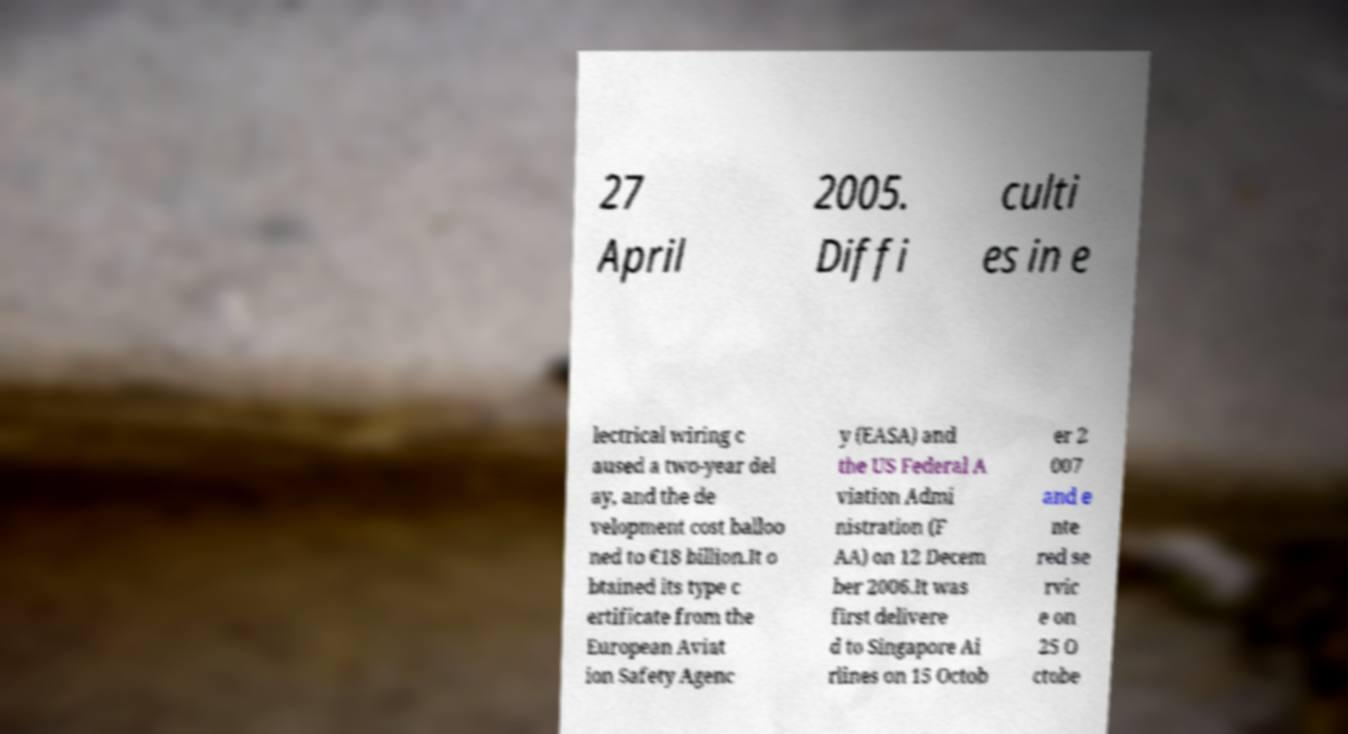Please identify and transcribe the text found in this image. 27 April 2005. Diffi culti es in e lectrical wiring c aused a two-year del ay, and the de velopment cost balloo ned to €18 billion.It o btained its type c ertificate from the European Aviat ion Safety Agenc y (EASA) and the US Federal A viation Admi nistration (F AA) on 12 Decem ber 2006.It was first delivere d to Singapore Ai rlines on 15 Octob er 2 007 and e nte red se rvic e on 25 O ctobe 